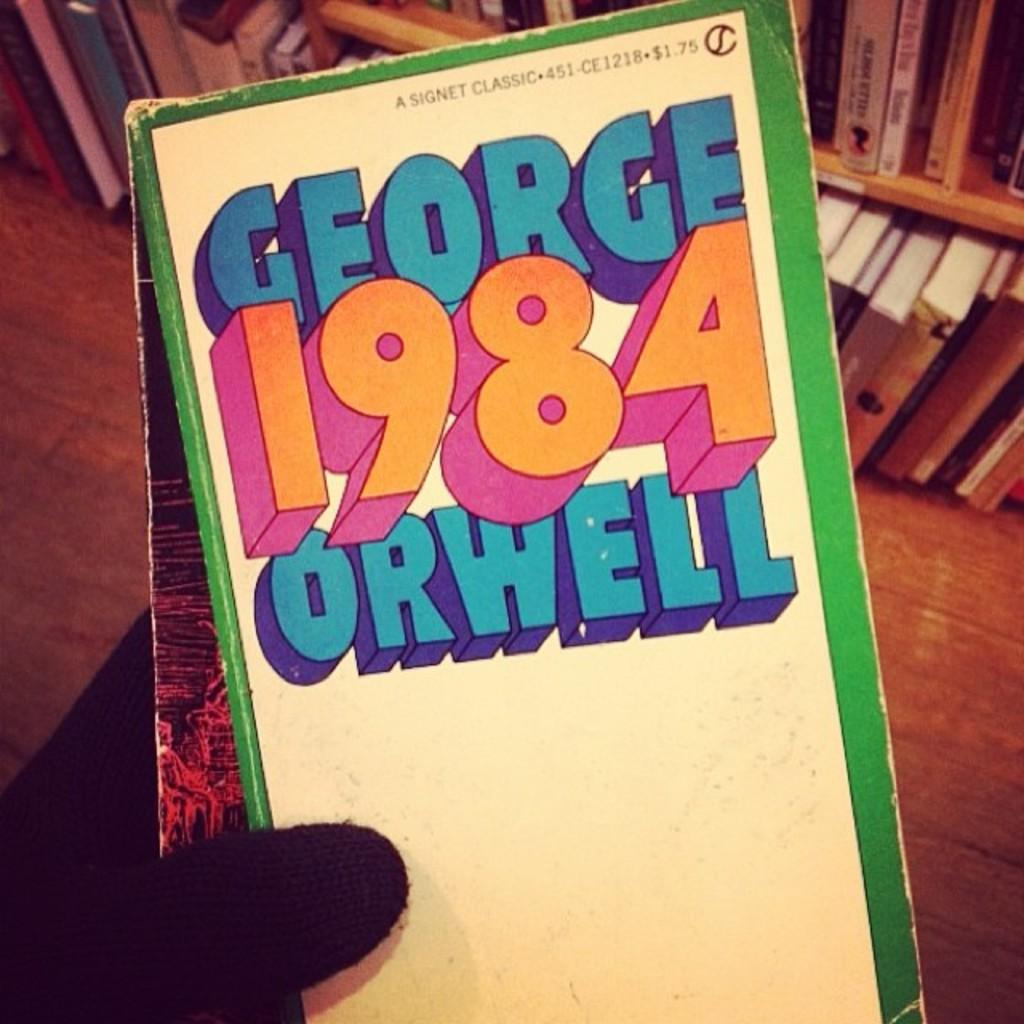<image>
Render a clear and concise summary of the photo. A hand wearing a black glove is holding up a copy of the book "1984". 